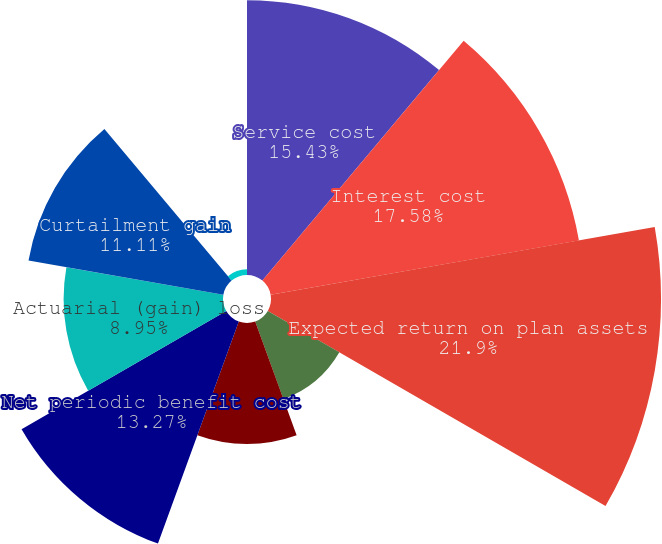<chart> <loc_0><loc_0><loc_500><loc_500><pie_chart><fcel>Service cost<fcel>Interest cost<fcel>Expected return on plan assets<fcel>Prior service credit<fcel>Actuarial loss<fcel>Net periodic benefit cost<fcel>Actuarial (gain) loss<fcel>Curtailment gain<fcel>Net periodic benefit cost (b)<nl><fcel>15.43%<fcel>17.58%<fcel>21.9%<fcel>4.64%<fcel>6.8%<fcel>13.27%<fcel>8.95%<fcel>11.11%<fcel>0.32%<nl></chart> 